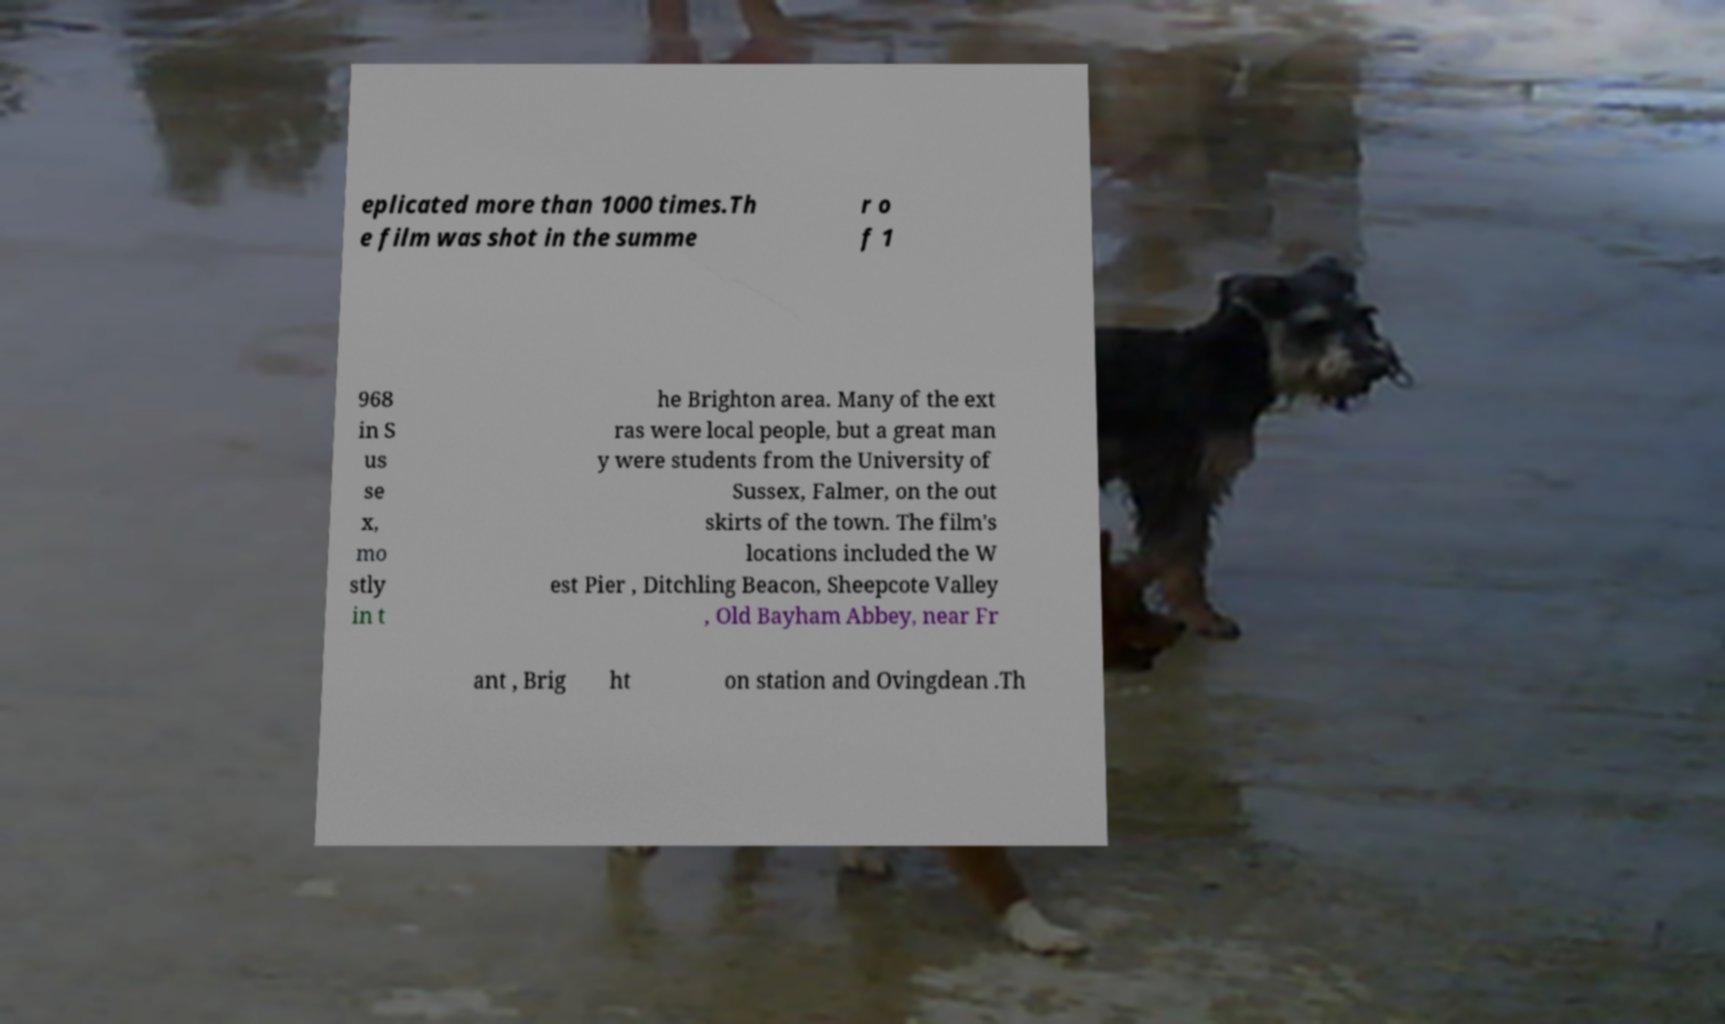Can you read and provide the text displayed in the image?This photo seems to have some interesting text. Can you extract and type it out for me? eplicated more than 1000 times.Th e film was shot in the summe r o f 1 968 in S us se x, mo stly in t he Brighton area. Many of the ext ras were local people, but a great man y were students from the University of Sussex, Falmer, on the out skirts of the town. The film's locations included the W est Pier , Ditchling Beacon, Sheepcote Valley , Old Bayham Abbey, near Fr ant , Brig ht on station and Ovingdean .Th 